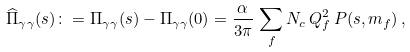<formula> <loc_0><loc_0><loc_500><loc_500>\widehat { \Pi } _ { \gamma \gamma } ( s ) \colon = \Pi _ { \gamma \gamma } ( s ) - \Pi _ { \gamma \gamma } ( 0 ) = \frac { \alpha } { 3 \pi } \, \sum _ { f } N _ { c } \, Q _ { f } ^ { 2 } \, P ( s , m _ { f } ) \, ,</formula> 